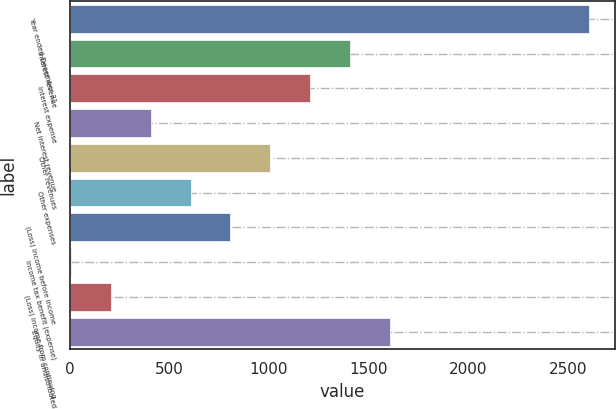Convert chart to OTSL. <chart><loc_0><loc_0><loc_500><loc_500><bar_chart><fcel>Year ended December 31<fcel>Interest revenue<fcel>Interest expense<fcel>Net interest revenue<fcel>Other revenues<fcel>Other expenses<fcel>(Loss) income before income<fcel>Income tax benefit (expense)<fcel>(Loss) income from continuing<fcel>Equity in undistributed<nl><fcel>2605.4<fcel>1406.6<fcel>1206.8<fcel>407.6<fcel>1007<fcel>607.4<fcel>807.2<fcel>8<fcel>207.8<fcel>1606.4<nl></chart> 